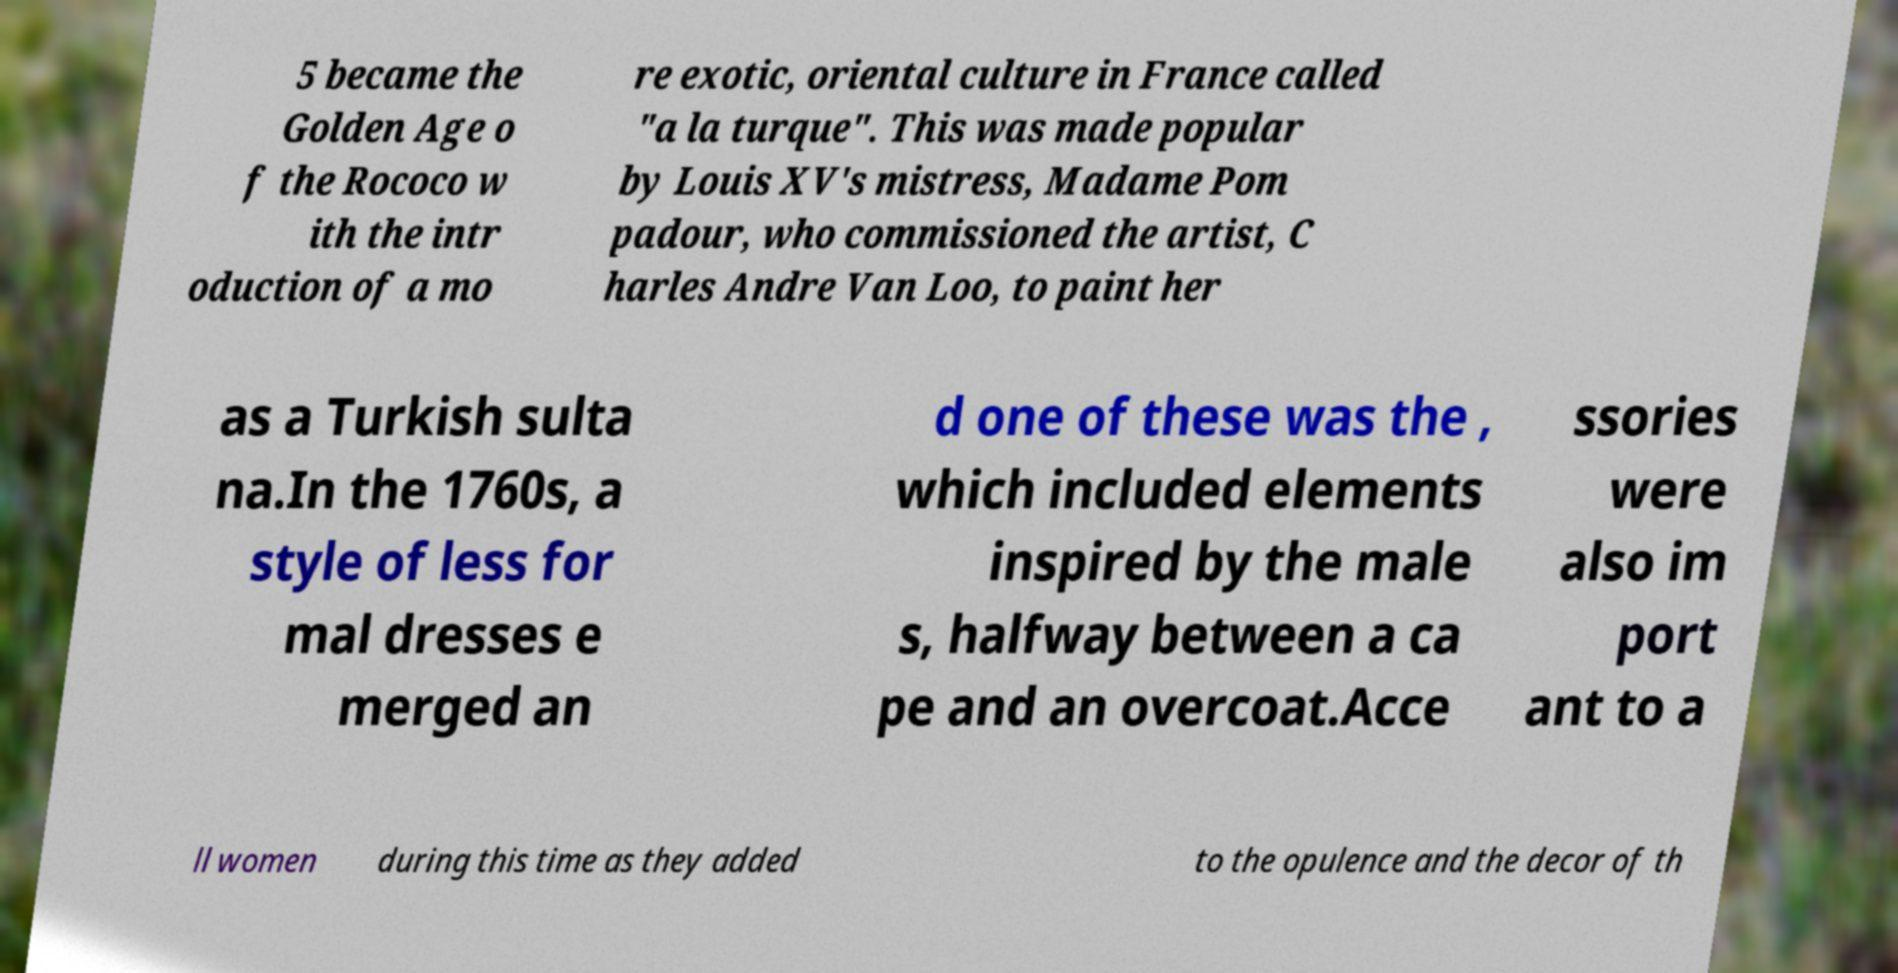Can you accurately transcribe the text from the provided image for me? 5 became the Golden Age o f the Rococo w ith the intr oduction of a mo re exotic, oriental culture in France called "a la turque". This was made popular by Louis XV's mistress, Madame Pom padour, who commissioned the artist, C harles Andre Van Loo, to paint her as a Turkish sulta na.In the 1760s, a style of less for mal dresses e merged an d one of these was the , which included elements inspired by the male s, halfway between a ca pe and an overcoat.Acce ssories were also im port ant to a ll women during this time as they added to the opulence and the decor of th 